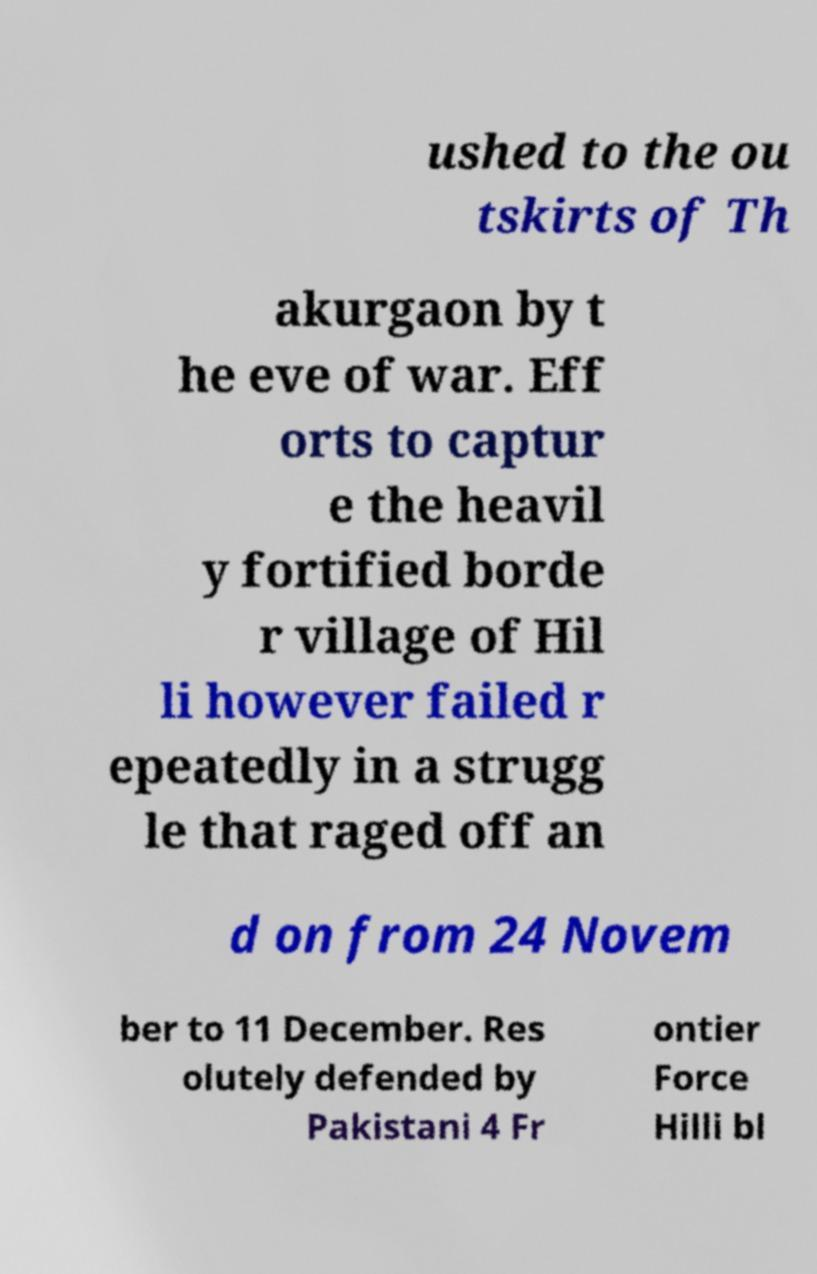Can you read and provide the text displayed in the image?This photo seems to have some interesting text. Can you extract and type it out for me? ushed to the ou tskirts of Th akurgaon by t he eve of war. Eff orts to captur e the heavil y fortified borde r village of Hil li however failed r epeatedly in a strugg le that raged off an d on from 24 Novem ber to 11 December. Res olutely defended by Pakistani 4 Fr ontier Force Hilli bl 